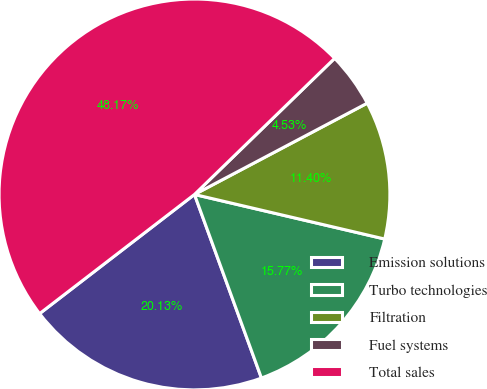<chart> <loc_0><loc_0><loc_500><loc_500><pie_chart><fcel>Emission solutions<fcel>Turbo technologies<fcel>Filtration<fcel>Fuel systems<fcel>Total sales<nl><fcel>20.13%<fcel>15.77%<fcel>11.4%<fcel>4.53%<fcel>48.17%<nl></chart> 